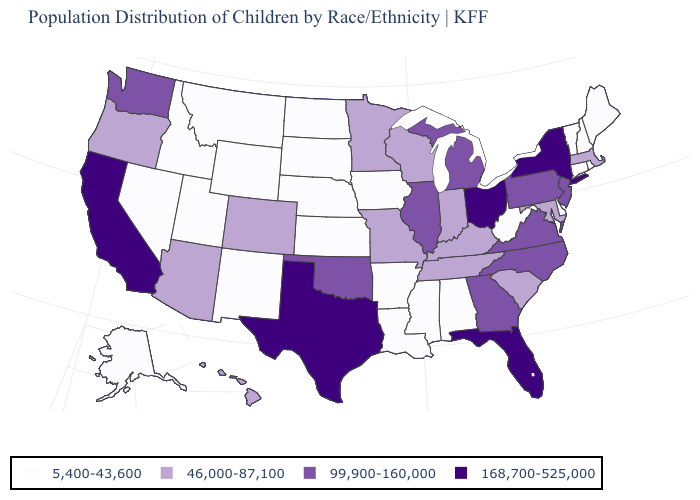Name the states that have a value in the range 5,400-43,600?
Be succinct. Alabama, Alaska, Arkansas, Connecticut, Delaware, Idaho, Iowa, Kansas, Louisiana, Maine, Mississippi, Montana, Nebraska, Nevada, New Hampshire, New Mexico, North Dakota, Rhode Island, South Dakota, Utah, Vermont, West Virginia, Wyoming. What is the value of Alaska?
Quick response, please. 5,400-43,600. Does West Virginia have the lowest value in the USA?
Keep it brief. Yes. What is the value of South Dakota?
Give a very brief answer. 5,400-43,600. Name the states that have a value in the range 99,900-160,000?
Keep it brief. Georgia, Illinois, Michigan, New Jersey, North Carolina, Oklahoma, Pennsylvania, Virginia, Washington. Is the legend a continuous bar?
Quick response, please. No. What is the lowest value in states that border North Dakota?
Short answer required. 5,400-43,600. What is the highest value in states that border North Dakota?
Answer briefly. 46,000-87,100. What is the value of Missouri?
Quick response, please. 46,000-87,100. Does Nebraska have a lower value than New York?
Concise answer only. Yes. What is the value of Hawaii?
Answer briefly. 46,000-87,100. What is the value of Florida?
Concise answer only. 168,700-525,000. Does Mississippi have the lowest value in the USA?
Write a very short answer. Yes. What is the highest value in states that border Maryland?
Be succinct. 99,900-160,000. Is the legend a continuous bar?
Answer briefly. No. 